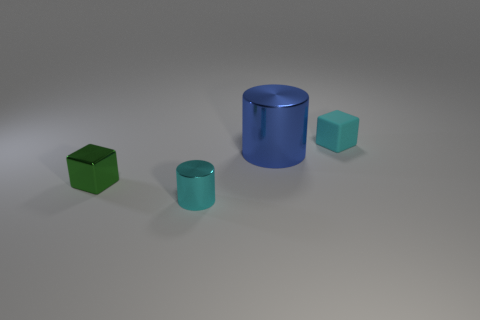Add 2 tiny purple cylinders. How many objects exist? 6 Subtract 0 purple balls. How many objects are left? 4 Subtract all tiny things. Subtract all green metallic blocks. How many objects are left? 0 Add 1 tiny green shiny objects. How many tiny green shiny objects are left? 2 Add 2 tiny cyan objects. How many tiny cyan objects exist? 4 